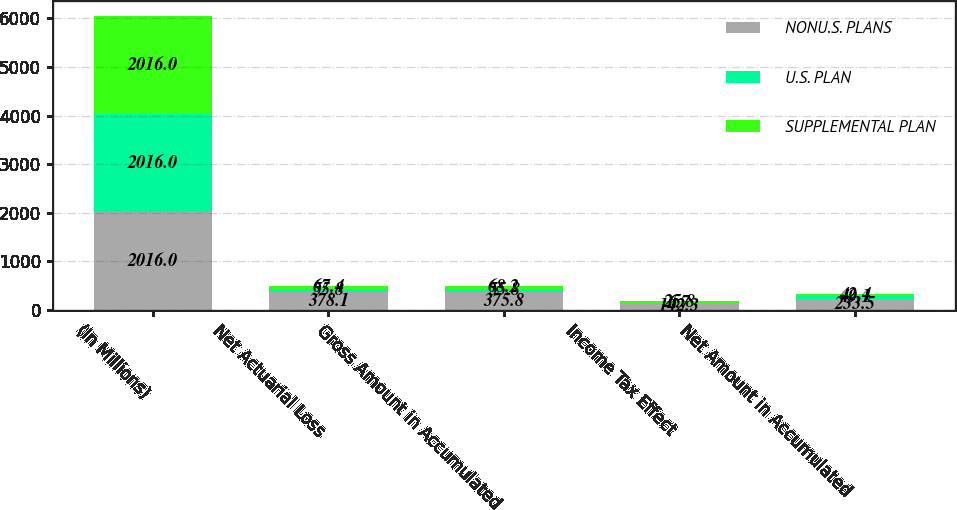Convert chart to OTSL. <chart><loc_0><loc_0><loc_500><loc_500><stacked_bar_chart><ecel><fcel>(In Millions)<fcel>Net Actuarial Loss<fcel>Gross Amount in Accumulated<fcel>Income Tax Effect<fcel>Net Amount in Accumulated<nl><fcel>NONU.S. PLANS<fcel>2016<fcel>378.1<fcel>375.8<fcel>142.3<fcel>233.5<nl><fcel>U.S. PLAN<fcel>2016<fcel>55.8<fcel>55.8<fcel>6.7<fcel>49.1<nl><fcel>SUPPLEMENTAL PLAN<fcel>2016<fcel>67.4<fcel>68.2<fcel>25.8<fcel>42.4<nl></chart> 